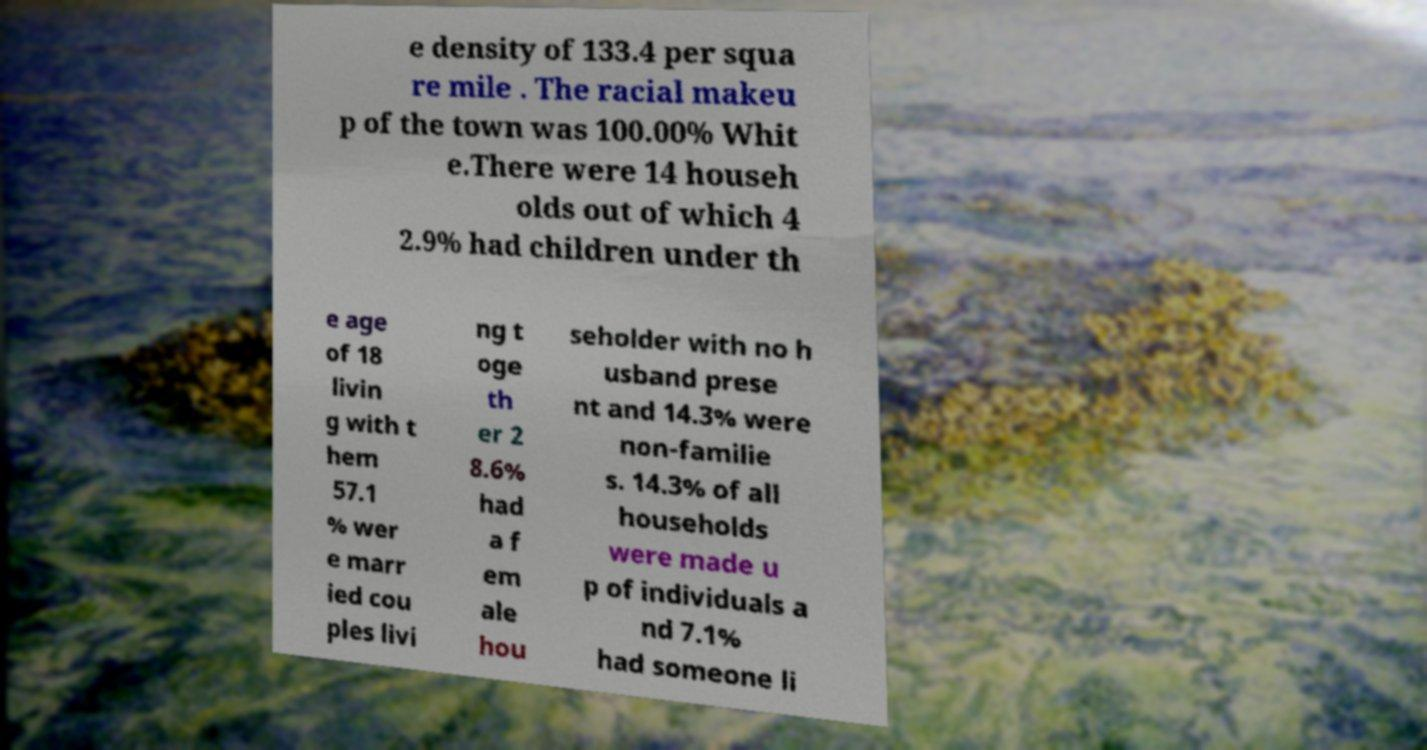Could you assist in decoding the text presented in this image and type it out clearly? e density of 133.4 per squa re mile . The racial makeu p of the town was 100.00% Whit e.There were 14 househ olds out of which 4 2.9% had children under th e age of 18 livin g with t hem 57.1 % wer e marr ied cou ples livi ng t oge th er 2 8.6% had a f em ale hou seholder with no h usband prese nt and 14.3% were non-familie s. 14.3% of all households were made u p of individuals a nd 7.1% had someone li 